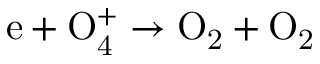<formula> <loc_0><loc_0><loc_500><loc_500>e + O _ { 4 } ^ { + } \to O _ { 2 } + O _ { 2 }</formula> 